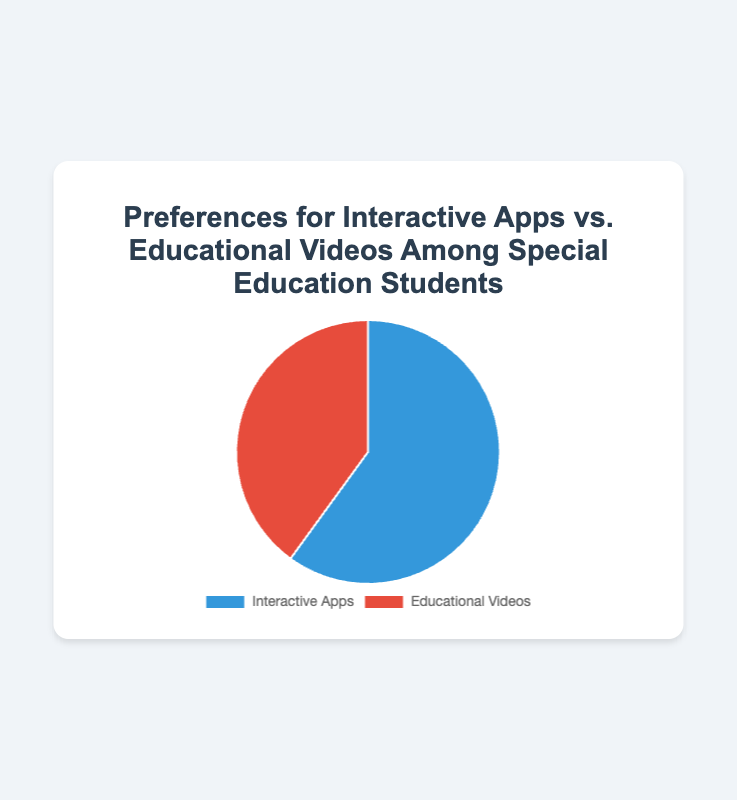1. What is the percentage preference for online professional development among special education teachers? The pie chart shows the percentage values of preferences, where 65% favor online professional development.
Answer: 65% 2. Compare the preferences for online vs. in-person professional development. Which one is preferred more and by how much? The chart indicates that 65% prefer online while 35% prefer in-person. Subtracting the two gives 65% - 35% = 30%.
Answer: Online by 30% 3. What fraction of the special education teachers prefer in-person professional development over the total? Given that 35% prefer in-person, the fraction is 35/100 which simplifies to 7/20.
Answer: 7/20 4. What is the ratio of online to in-person professional development preferences? The percentages are 65% for online and 35% for in-person. The ratio is 65:35, which simplifies to 13:7.
Answer: 13:7 5. Calculate the combined percentage of teachers who prefer either online or in-person professional development. Since the total must be 100%, the combined percentage is 100%.
Answer: 100% 1. What is the percentage preference for interactive apps among special education students? The pie chart indicates that 60% prefer interactive apps.
Answer: 60% 2. Compare the preferences for interactive apps vs. educational videos. Which one is preferred more and by how much? The chart shows 60% prefer interactive apps while 40% prefer educational videos. Subtracting these gives 60% - 40% = 20%.
Answer: Interactive apps by 20% 3. What fraction of special education students prefer educational videos? Given that 40% prefer educational videos, the fraction is 40/100 which simplifies to 2/5.
Answer: 2/5 4. What is the ratio of preferences for interactive apps to educational videos? The percentages are 60% for interactive apps and 40% for educational videos. The ratio is 60:40, which simplifies to 3:2.
Answer: 3:2 5. If you were to randomly select a student, what are the chances that they prefer interactive apps over educational videos? The percentage of students who prefer interactive apps is 60%, hence the probability is 60 out of 100.
Answer: 60% 6. How much greater is the preference for interactive apps compared to educational videos? The pie chart shows a 60% preference for interactive apps and a 40% preference for educational videos. The difference is 60% - 40% = 20%.
Answer: 20% 